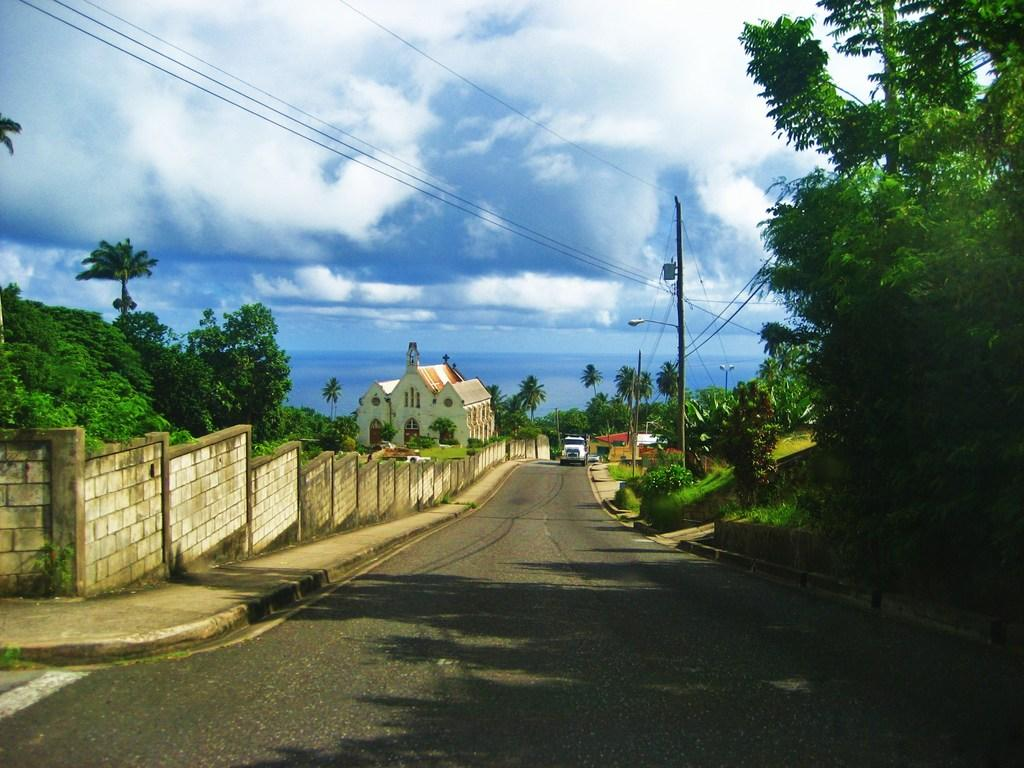What is the main subject of the image? There is a vehicle on a road in the image. What can be seen on the left side of the image? There is a wall, trees, and a house on the left side of the image. What type of vegetation is present on both sides of the image? There are trees on both the left and right sides of the image. What other structures or objects can be seen in the image? There are poles and wires ines in the image. What is visible in the background of the image? The sky is visible in the image. What type of pickle is being used to polish the vehicle in the image? There is no pickle present in the image, nor is there any indication that the vehicle is being polished. 